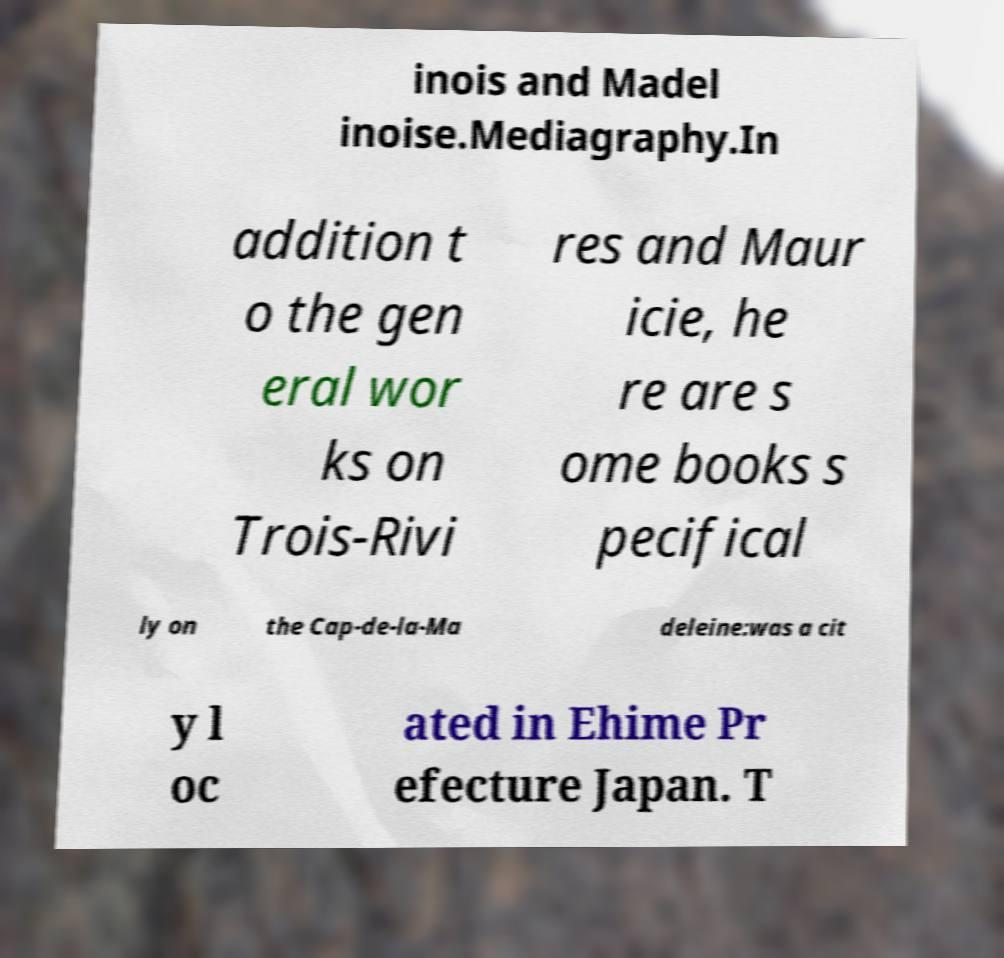There's text embedded in this image that I need extracted. Can you transcribe it verbatim? inois and Madel inoise.Mediagraphy.In addition t o the gen eral wor ks on Trois-Rivi res and Maur icie, he re are s ome books s pecifical ly on the Cap-de-la-Ma deleine:was a cit y l oc ated in Ehime Pr efecture Japan. T 